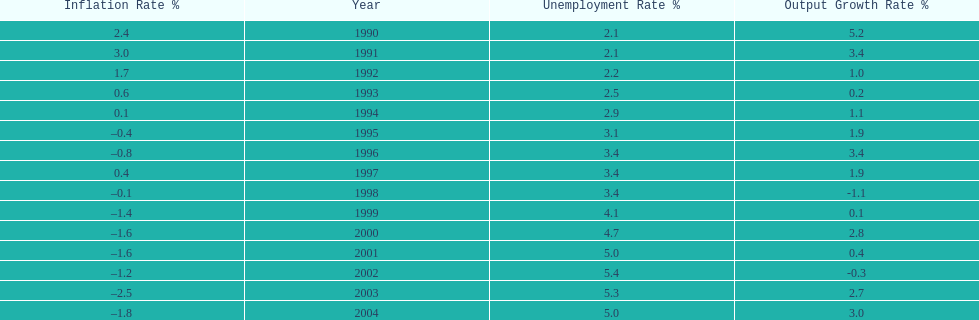Were the highest unemployment rates in japan before or after the year 2000? After. 